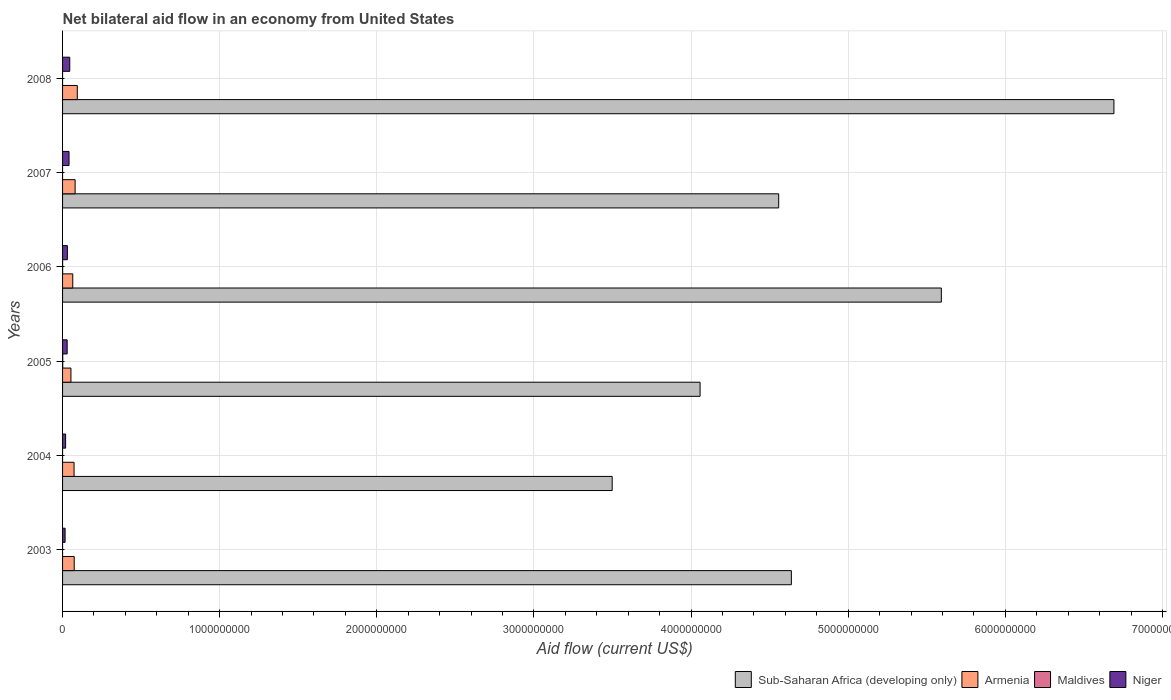In how many cases, is the number of bars for a given year not equal to the number of legend labels?
Make the answer very short. 4. What is the net bilateral aid flow in Niger in 2003?
Keep it short and to the point. 1.61e+07. Across all years, what is the maximum net bilateral aid flow in Sub-Saharan Africa (developing only)?
Ensure brevity in your answer.  6.69e+09. Across all years, what is the minimum net bilateral aid flow in Sub-Saharan Africa (developing only)?
Your answer should be compact. 3.50e+09. What is the total net bilateral aid flow in Niger in the graph?
Provide a succinct answer. 1.82e+08. What is the difference between the net bilateral aid flow in Armenia in 2003 and that in 2006?
Offer a very short reply. 9.31e+06. What is the difference between the net bilateral aid flow in Niger in 2006 and the net bilateral aid flow in Armenia in 2008?
Keep it short and to the point. -6.32e+07. What is the average net bilateral aid flow in Armenia per year?
Your answer should be very brief. 7.32e+07. In the year 2003, what is the difference between the net bilateral aid flow in Niger and net bilateral aid flow in Sub-Saharan Africa (developing only)?
Provide a succinct answer. -4.62e+09. In how many years, is the net bilateral aid flow in Sub-Saharan Africa (developing only) greater than 5200000000 US$?
Your answer should be very brief. 2. What is the ratio of the net bilateral aid flow in Armenia in 2005 to that in 2006?
Your answer should be very brief. 0.82. Is the net bilateral aid flow in Armenia in 2004 less than that in 2008?
Provide a succinct answer. Yes. Is the difference between the net bilateral aid flow in Niger in 2004 and 2005 greater than the difference between the net bilateral aid flow in Sub-Saharan Africa (developing only) in 2004 and 2005?
Offer a very short reply. Yes. What is the difference between the highest and the second highest net bilateral aid flow in Armenia?
Provide a succinct answer. 1.39e+07. What is the difference between the highest and the lowest net bilateral aid flow in Sub-Saharan Africa (developing only)?
Make the answer very short. 3.19e+09. In how many years, is the net bilateral aid flow in Armenia greater than the average net bilateral aid flow in Armenia taken over all years?
Keep it short and to the point. 3. Is the sum of the net bilateral aid flow in Niger in 2005 and 2007 greater than the maximum net bilateral aid flow in Maldives across all years?
Provide a succinct answer. Yes. Is it the case that in every year, the sum of the net bilateral aid flow in Armenia and net bilateral aid flow in Maldives is greater than the net bilateral aid flow in Sub-Saharan Africa (developing only)?
Keep it short and to the point. No. How many years are there in the graph?
Offer a very short reply. 6. Are the values on the major ticks of X-axis written in scientific E-notation?
Ensure brevity in your answer.  No. Does the graph contain any zero values?
Offer a terse response. Yes. Does the graph contain grids?
Offer a very short reply. Yes. Where does the legend appear in the graph?
Offer a terse response. Bottom right. How many legend labels are there?
Your response must be concise. 4. How are the legend labels stacked?
Make the answer very short. Horizontal. What is the title of the graph?
Give a very brief answer. Net bilateral aid flow in an economy from United States. What is the Aid flow (current US$) in Sub-Saharan Africa (developing only) in 2003?
Your response must be concise. 4.64e+09. What is the Aid flow (current US$) in Armenia in 2003?
Offer a terse response. 7.42e+07. What is the Aid flow (current US$) in Maldives in 2003?
Ensure brevity in your answer.  0. What is the Aid flow (current US$) in Niger in 2003?
Provide a short and direct response. 1.61e+07. What is the Aid flow (current US$) of Sub-Saharan Africa (developing only) in 2004?
Ensure brevity in your answer.  3.50e+09. What is the Aid flow (current US$) in Armenia in 2004?
Your answer should be very brief. 7.31e+07. What is the Aid flow (current US$) in Maldives in 2004?
Your answer should be very brief. 0. What is the Aid flow (current US$) in Niger in 2004?
Your answer should be compact. 1.93e+07. What is the Aid flow (current US$) of Sub-Saharan Africa (developing only) in 2005?
Your answer should be very brief. 4.06e+09. What is the Aid flow (current US$) of Armenia in 2005?
Offer a very short reply. 5.33e+07. What is the Aid flow (current US$) of Maldives in 2005?
Your answer should be compact. 1.09e+06. What is the Aid flow (current US$) of Niger in 2005?
Provide a short and direct response. 2.92e+07. What is the Aid flow (current US$) of Sub-Saharan Africa (developing only) in 2006?
Keep it short and to the point. 5.59e+09. What is the Aid flow (current US$) of Armenia in 2006?
Offer a very short reply. 6.49e+07. What is the Aid flow (current US$) of Niger in 2006?
Offer a terse response. 3.06e+07. What is the Aid flow (current US$) of Sub-Saharan Africa (developing only) in 2007?
Your answer should be very brief. 4.56e+09. What is the Aid flow (current US$) of Armenia in 2007?
Provide a succinct answer. 7.99e+07. What is the Aid flow (current US$) of Niger in 2007?
Provide a short and direct response. 4.13e+07. What is the Aid flow (current US$) in Sub-Saharan Africa (developing only) in 2008?
Ensure brevity in your answer.  6.69e+09. What is the Aid flow (current US$) in Armenia in 2008?
Ensure brevity in your answer.  9.38e+07. What is the Aid flow (current US$) of Maldives in 2008?
Offer a terse response. 0. What is the Aid flow (current US$) of Niger in 2008?
Your answer should be compact. 4.59e+07. Across all years, what is the maximum Aid flow (current US$) of Sub-Saharan Africa (developing only)?
Provide a short and direct response. 6.69e+09. Across all years, what is the maximum Aid flow (current US$) of Armenia?
Give a very brief answer. 9.38e+07. Across all years, what is the maximum Aid flow (current US$) of Maldives?
Your answer should be very brief. 1.09e+06. Across all years, what is the maximum Aid flow (current US$) in Niger?
Your answer should be compact. 4.59e+07. Across all years, what is the minimum Aid flow (current US$) in Sub-Saharan Africa (developing only)?
Offer a terse response. 3.50e+09. Across all years, what is the minimum Aid flow (current US$) of Armenia?
Ensure brevity in your answer.  5.33e+07. Across all years, what is the minimum Aid flow (current US$) of Maldives?
Offer a terse response. 0. Across all years, what is the minimum Aid flow (current US$) in Niger?
Provide a succinct answer. 1.61e+07. What is the total Aid flow (current US$) of Sub-Saharan Africa (developing only) in the graph?
Your answer should be compact. 2.90e+1. What is the total Aid flow (current US$) in Armenia in the graph?
Make the answer very short. 4.39e+08. What is the total Aid flow (current US$) of Maldives in the graph?
Offer a very short reply. 1.46e+06. What is the total Aid flow (current US$) of Niger in the graph?
Your answer should be compact. 1.82e+08. What is the difference between the Aid flow (current US$) of Sub-Saharan Africa (developing only) in 2003 and that in 2004?
Provide a short and direct response. 1.14e+09. What is the difference between the Aid flow (current US$) in Armenia in 2003 and that in 2004?
Make the answer very short. 1.05e+06. What is the difference between the Aid flow (current US$) of Niger in 2003 and that in 2004?
Your response must be concise. -3.19e+06. What is the difference between the Aid flow (current US$) in Sub-Saharan Africa (developing only) in 2003 and that in 2005?
Give a very brief answer. 5.81e+08. What is the difference between the Aid flow (current US$) of Armenia in 2003 and that in 2005?
Provide a succinct answer. 2.09e+07. What is the difference between the Aid flow (current US$) in Niger in 2003 and that in 2005?
Offer a terse response. -1.31e+07. What is the difference between the Aid flow (current US$) in Sub-Saharan Africa (developing only) in 2003 and that in 2006?
Your answer should be very brief. -9.54e+08. What is the difference between the Aid flow (current US$) of Armenia in 2003 and that in 2006?
Provide a short and direct response. 9.31e+06. What is the difference between the Aid flow (current US$) in Niger in 2003 and that in 2006?
Your response must be concise. -1.44e+07. What is the difference between the Aid flow (current US$) of Sub-Saharan Africa (developing only) in 2003 and that in 2007?
Your answer should be very brief. 8.07e+07. What is the difference between the Aid flow (current US$) in Armenia in 2003 and that in 2007?
Provide a succinct answer. -5.73e+06. What is the difference between the Aid flow (current US$) of Niger in 2003 and that in 2007?
Keep it short and to the point. -2.52e+07. What is the difference between the Aid flow (current US$) of Sub-Saharan Africa (developing only) in 2003 and that in 2008?
Ensure brevity in your answer.  -2.05e+09. What is the difference between the Aid flow (current US$) in Armenia in 2003 and that in 2008?
Your response must be concise. -1.96e+07. What is the difference between the Aid flow (current US$) of Niger in 2003 and that in 2008?
Give a very brief answer. -2.97e+07. What is the difference between the Aid flow (current US$) in Sub-Saharan Africa (developing only) in 2004 and that in 2005?
Ensure brevity in your answer.  -5.59e+08. What is the difference between the Aid flow (current US$) of Armenia in 2004 and that in 2005?
Provide a short and direct response. 1.99e+07. What is the difference between the Aid flow (current US$) of Niger in 2004 and that in 2005?
Your answer should be very brief. -9.88e+06. What is the difference between the Aid flow (current US$) of Sub-Saharan Africa (developing only) in 2004 and that in 2006?
Provide a short and direct response. -2.09e+09. What is the difference between the Aid flow (current US$) of Armenia in 2004 and that in 2006?
Your answer should be very brief. 8.26e+06. What is the difference between the Aid flow (current US$) in Niger in 2004 and that in 2006?
Keep it short and to the point. -1.12e+07. What is the difference between the Aid flow (current US$) of Sub-Saharan Africa (developing only) in 2004 and that in 2007?
Your answer should be compact. -1.06e+09. What is the difference between the Aid flow (current US$) in Armenia in 2004 and that in 2007?
Provide a succinct answer. -6.78e+06. What is the difference between the Aid flow (current US$) of Niger in 2004 and that in 2007?
Offer a terse response. -2.20e+07. What is the difference between the Aid flow (current US$) in Sub-Saharan Africa (developing only) in 2004 and that in 2008?
Give a very brief answer. -3.19e+09. What is the difference between the Aid flow (current US$) of Armenia in 2004 and that in 2008?
Your response must be concise. -2.06e+07. What is the difference between the Aid flow (current US$) of Niger in 2004 and that in 2008?
Ensure brevity in your answer.  -2.65e+07. What is the difference between the Aid flow (current US$) in Sub-Saharan Africa (developing only) in 2005 and that in 2006?
Your response must be concise. -1.54e+09. What is the difference between the Aid flow (current US$) in Armenia in 2005 and that in 2006?
Your answer should be very brief. -1.16e+07. What is the difference between the Aid flow (current US$) of Maldives in 2005 and that in 2006?
Offer a terse response. 7.20e+05. What is the difference between the Aid flow (current US$) of Niger in 2005 and that in 2006?
Your answer should be very brief. -1.36e+06. What is the difference between the Aid flow (current US$) of Sub-Saharan Africa (developing only) in 2005 and that in 2007?
Ensure brevity in your answer.  -5.00e+08. What is the difference between the Aid flow (current US$) of Armenia in 2005 and that in 2007?
Give a very brief answer. -2.67e+07. What is the difference between the Aid flow (current US$) in Niger in 2005 and that in 2007?
Keep it short and to the point. -1.21e+07. What is the difference between the Aid flow (current US$) of Sub-Saharan Africa (developing only) in 2005 and that in 2008?
Offer a terse response. -2.63e+09. What is the difference between the Aid flow (current US$) of Armenia in 2005 and that in 2008?
Provide a short and direct response. -4.05e+07. What is the difference between the Aid flow (current US$) of Niger in 2005 and that in 2008?
Offer a terse response. -1.67e+07. What is the difference between the Aid flow (current US$) of Sub-Saharan Africa (developing only) in 2006 and that in 2007?
Provide a short and direct response. 1.04e+09. What is the difference between the Aid flow (current US$) in Armenia in 2006 and that in 2007?
Your answer should be compact. -1.50e+07. What is the difference between the Aid flow (current US$) in Niger in 2006 and that in 2007?
Give a very brief answer. -1.07e+07. What is the difference between the Aid flow (current US$) of Sub-Saharan Africa (developing only) in 2006 and that in 2008?
Your answer should be compact. -1.10e+09. What is the difference between the Aid flow (current US$) in Armenia in 2006 and that in 2008?
Give a very brief answer. -2.89e+07. What is the difference between the Aid flow (current US$) in Niger in 2006 and that in 2008?
Provide a short and direct response. -1.53e+07. What is the difference between the Aid flow (current US$) in Sub-Saharan Africa (developing only) in 2007 and that in 2008?
Your response must be concise. -2.13e+09. What is the difference between the Aid flow (current US$) of Armenia in 2007 and that in 2008?
Ensure brevity in your answer.  -1.39e+07. What is the difference between the Aid flow (current US$) of Niger in 2007 and that in 2008?
Your answer should be compact. -4.58e+06. What is the difference between the Aid flow (current US$) in Sub-Saharan Africa (developing only) in 2003 and the Aid flow (current US$) in Armenia in 2004?
Offer a very short reply. 4.57e+09. What is the difference between the Aid flow (current US$) of Sub-Saharan Africa (developing only) in 2003 and the Aid flow (current US$) of Niger in 2004?
Your response must be concise. 4.62e+09. What is the difference between the Aid flow (current US$) of Armenia in 2003 and the Aid flow (current US$) of Niger in 2004?
Your answer should be very brief. 5.49e+07. What is the difference between the Aid flow (current US$) of Sub-Saharan Africa (developing only) in 2003 and the Aid flow (current US$) of Armenia in 2005?
Make the answer very short. 4.58e+09. What is the difference between the Aid flow (current US$) of Sub-Saharan Africa (developing only) in 2003 and the Aid flow (current US$) of Maldives in 2005?
Provide a succinct answer. 4.64e+09. What is the difference between the Aid flow (current US$) in Sub-Saharan Africa (developing only) in 2003 and the Aid flow (current US$) in Niger in 2005?
Make the answer very short. 4.61e+09. What is the difference between the Aid flow (current US$) in Armenia in 2003 and the Aid flow (current US$) in Maldives in 2005?
Give a very brief answer. 7.31e+07. What is the difference between the Aid flow (current US$) of Armenia in 2003 and the Aid flow (current US$) of Niger in 2005?
Your response must be concise. 4.50e+07. What is the difference between the Aid flow (current US$) in Sub-Saharan Africa (developing only) in 2003 and the Aid flow (current US$) in Armenia in 2006?
Offer a terse response. 4.57e+09. What is the difference between the Aid flow (current US$) in Sub-Saharan Africa (developing only) in 2003 and the Aid flow (current US$) in Maldives in 2006?
Keep it short and to the point. 4.64e+09. What is the difference between the Aid flow (current US$) in Sub-Saharan Africa (developing only) in 2003 and the Aid flow (current US$) in Niger in 2006?
Offer a very short reply. 4.61e+09. What is the difference between the Aid flow (current US$) in Armenia in 2003 and the Aid flow (current US$) in Maldives in 2006?
Offer a very short reply. 7.38e+07. What is the difference between the Aid flow (current US$) in Armenia in 2003 and the Aid flow (current US$) in Niger in 2006?
Keep it short and to the point. 4.36e+07. What is the difference between the Aid flow (current US$) in Sub-Saharan Africa (developing only) in 2003 and the Aid flow (current US$) in Armenia in 2007?
Your response must be concise. 4.56e+09. What is the difference between the Aid flow (current US$) of Sub-Saharan Africa (developing only) in 2003 and the Aid flow (current US$) of Niger in 2007?
Ensure brevity in your answer.  4.60e+09. What is the difference between the Aid flow (current US$) in Armenia in 2003 and the Aid flow (current US$) in Niger in 2007?
Your answer should be very brief. 3.29e+07. What is the difference between the Aid flow (current US$) of Sub-Saharan Africa (developing only) in 2003 and the Aid flow (current US$) of Armenia in 2008?
Offer a very short reply. 4.54e+09. What is the difference between the Aid flow (current US$) in Sub-Saharan Africa (developing only) in 2003 and the Aid flow (current US$) in Niger in 2008?
Give a very brief answer. 4.59e+09. What is the difference between the Aid flow (current US$) in Armenia in 2003 and the Aid flow (current US$) in Niger in 2008?
Offer a terse response. 2.83e+07. What is the difference between the Aid flow (current US$) in Sub-Saharan Africa (developing only) in 2004 and the Aid flow (current US$) in Armenia in 2005?
Your answer should be compact. 3.44e+09. What is the difference between the Aid flow (current US$) of Sub-Saharan Africa (developing only) in 2004 and the Aid flow (current US$) of Maldives in 2005?
Give a very brief answer. 3.50e+09. What is the difference between the Aid flow (current US$) of Sub-Saharan Africa (developing only) in 2004 and the Aid flow (current US$) of Niger in 2005?
Keep it short and to the point. 3.47e+09. What is the difference between the Aid flow (current US$) of Armenia in 2004 and the Aid flow (current US$) of Maldives in 2005?
Offer a very short reply. 7.20e+07. What is the difference between the Aid flow (current US$) in Armenia in 2004 and the Aid flow (current US$) in Niger in 2005?
Your answer should be compact. 4.39e+07. What is the difference between the Aid flow (current US$) in Sub-Saharan Africa (developing only) in 2004 and the Aid flow (current US$) in Armenia in 2006?
Keep it short and to the point. 3.43e+09. What is the difference between the Aid flow (current US$) in Sub-Saharan Africa (developing only) in 2004 and the Aid flow (current US$) in Maldives in 2006?
Offer a very short reply. 3.50e+09. What is the difference between the Aid flow (current US$) of Sub-Saharan Africa (developing only) in 2004 and the Aid flow (current US$) of Niger in 2006?
Provide a succinct answer. 3.47e+09. What is the difference between the Aid flow (current US$) of Armenia in 2004 and the Aid flow (current US$) of Maldives in 2006?
Provide a succinct answer. 7.28e+07. What is the difference between the Aid flow (current US$) in Armenia in 2004 and the Aid flow (current US$) in Niger in 2006?
Give a very brief answer. 4.26e+07. What is the difference between the Aid flow (current US$) in Sub-Saharan Africa (developing only) in 2004 and the Aid flow (current US$) in Armenia in 2007?
Keep it short and to the point. 3.42e+09. What is the difference between the Aid flow (current US$) in Sub-Saharan Africa (developing only) in 2004 and the Aid flow (current US$) in Niger in 2007?
Make the answer very short. 3.46e+09. What is the difference between the Aid flow (current US$) of Armenia in 2004 and the Aid flow (current US$) of Niger in 2007?
Give a very brief answer. 3.19e+07. What is the difference between the Aid flow (current US$) in Sub-Saharan Africa (developing only) in 2004 and the Aid flow (current US$) in Armenia in 2008?
Offer a terse response. 3.40e+09. What is the difference between the Aid flow (current US$) of Sub-Saharan Africa (developing only) in 2004 and the Aid flow (current US$) of Niger in 2008?
Give a very brief answer. 3.45e+09. What is the difference between the Aid flow (current US$) of Armenia in 2004 and the Aid flow (current US$) of Niger in 2008?
Keep it short and to the point. 2.73e+07. What is the difference between the Aid flow (current US$) of Sub-Saharan Africa (developing only) in 2005 and the Aid flow (current US$) of Armenia in 2006?
Offer a terse response. 3.99e+09. What is the difference between the Aid flow (current US$) in Sub-Saharan Africa (developing only) in 2005 and the Aid flow (current US$) in Maldives in 2006?
Make the answer very short. 4.06e+09. What is the difference between the Aid flow (current US$) of Sub-Saharan Africa (developing only) in 2005 and the Aid flow (current US$) of Niger in 2006?
Keep it short and to the point. 4.03e+09. What is the difference between the Aid flow (current US$) in Armenia in 2005 and the Aid flow (current US$) in Maldives in 2006?
Your answer should be very brief. 5.29e+07. What is the difference between the Aid flow (current US$) of Armenia in 2005 and the Aid flow (current US$) of Niger in 2006?
Offer a very short reply. 2.27e+07. What is the difference between the Aid flow (current US$) of Maldives in 2005 and the Aid flow (current US$) of Niger in 2006?
Your answer should be compact. -2.95e+07. What is the difference between the Aid flow (current US$) in Sub-Saharan Africa (developing only) in 2005 and the Aid flow (current US$) in Armenia in 2007?
Your answer should be very brief. 3.98e+09. What is the difference between the Aid flow (current US$) of Sub-Saharan Africa (developing only) in 2005 and the Aid flow (current US$) of Niger in 2007?
Make the answer very short. 4.02e+09. What is the difference between the Aid flow (current US$) of Armenia in 2005 and the Aid flow (current US$) of Niger in 2007?
Keep it short and to the point. 1.20e+07. What is the difference between the Aid flow (current US$) in Maldives in 2005 and the Aid flow (current US$) in Niger in 2007?
Give a very brief answer. -4.02e+07. What is the difference between the Aid flow (current US$) in Sub-Saharan Africa (developing only) in 2005 and the Aid flow (current US$) in Armenia in 2008?
Provide a succinct answer. 3.96e+09. What is the difference between the Aid flow (current US$) of Sub-Saharan Africa (developing only) in 2005 and the Aid flow (current US$) of Niger in 2008?
Offer a terse response. 4.01e+09. What is the difference between the Aid flow (current US$) in Armenia in 2005 and the Aid flow (current US$) in Niger in 2008?
Offer a very short reply. 7.40e+06. What is the difference between the Aid flow (current US$) of Maldives in 2005 and the Aid flow (current US$) of Niger in 2008?
Make the answer very short. -4.48e+07. What is the difference between the Aid flow (current US$) of Sub-Saharan Africa (developing only) in 2006 and the Aid flow (current US$) of Armenia in 2007?
Keep it short and to the point. 5.51e+09. What is the difference between the Aid flow (current US$) of Sub-Saharan Africa (developing only) in 2006 and the Aid flow (current US$) of Niger in 2007?
Make the answer very short. 5.55e+09. What is the difference between the Aid flow (current US$) of Armenia in 2006 and the Aid flow (current US$) of Niger in 2007?
Offer a very short reply. 2.36e+07. What is the difference between the Aid flow (current US$) of Maldives in 2006 and the Aid flow (current US$) of Niger in 2007?
Offer a terse response. -4.09e+07. What is the difference between the Aid flow (current US$) in Sub-Saharan Africa (developing only) in 2006 and the Aid flow (current US$) in Armenia in 2008?
Ensure brevity in your answer.  5.50e+09. What is the difference between the Aid flow (current US$) in Sub-Saharan Africa (developing only) in 2006 and the Aid flow (current US$) in Niger in 2008?
Keep it short and to the point. 5.55e+09. What is the difference between the Aid flow (current US$) in Armenia in 2006 and the Aid flow (current US$) in Niger in 2008?
Provide a short and direct response. 1.90e+07. What is the difference between the Aid flow (current US$) in Maldives in 2006 and the Aid flow (current US$) in Niger in 2008?
Offer a very short reply. -4.55e+07. What is the difference between the Aid flow (current US$) of Sub-Saharan Africa (developing only) in 2007 and the Aid flow (current US$) of Armenia in 2008?
Offer a terse response. 4.46e+09. What is the difference between the Aid flow (current US$) of Sub-Saharan Africa (developing only) in 2007 and the Aid flow (current US$) of Niger in 2008?
Offer a terse response. 4.51e+09. What is the difference between the Aid flow (current US$) in Armenia in 2007 and the Aid flow (current US$) in Niger in 2008?
Keep it short and to the point. 3.41e+07. What is the average Aid flow (current US$) in Sub-Saharan Africa (developing only) per year?
Provide a succinct answer. 4.84e+09. What is the average Aid flow (current US$) of Armenia per year?
Provide a short and direct response. 7.32e+07. What is the average Aid flow (current US$) in Maldives per year?
Your answer should be very brief. 2.43e+05. What is the average Aid flow (current US$) in Niger per year?
Keep it short and to the point. 3.04e+07. In the year 2003, what is the difference between the Aid flow (current US$) of Sub-Saharan Africa (developing only) and Aid flow (current US$) of Armenia?
Offer a terse response. 4.56e+09. In the year 2003, what is the difference between the Aid flow (current US$) in Sub-Saharan Africa (developing only) and Aid flow (current US$) in Niger?
Provide a succinct answer. 4.62e+09. In the year 2003, what is the difference between the Aid flow (current US$) of Armenia and Aid flow (current US$) of Niger?
Your response must be concise. 5.81e+07. In the year 2004, what is the difference between the Aid flow (current US$) of Sub-Saharan Africa (developing only) and Aid flow (current US$) of Armenia?
Provide a succinct answer. 3.42e+09. In the year 2004, what is the difference between the Aid flow (current US$) of Sub-Saharan Africa (developing only) and Aid flow (current US$) of Niger?
Give a very brief answer. 3.48e+09. In the year 2004, what is the difference between the Aid flow (current US$) in Armenia and Aid flow (current US$) in Niger?
Keep it short and to the point. 5.38e+07. In the year 2005, what is the difference between the Aid flow (current US$) of Sub-Saharan Africa (developing only) and Aid flow (current US$) of Armenia?
Provide a succinct answer. 4.00e+09. In the year 2005, what is the difference between the Aid flow (current US$) in Sub-Saharan Africa (developing only) and Aid flow (current US$) in Maldives?
Ensure brevity in your answer.  4.06e+09. In the year 2005, what is the difference between the Aid flow (current US$) of Sub-Saharan Africa (developing only) and Aid flow (current US$) of Niger?
Provide a succinct answer. 4.03e+09. In the year 2005, what is the difference between the Aid flow (current US$) in Armenia and Aid flow (current US$) in Maldives?
Ensure brevity in your answer.  5.22e+07. In the year 2005, what is the difference between the Aid flow (current US$) in Armenia and Aid flow (current US$) in Niger?
Your response must be concise. 2.41e+07. In the year 2005, what is the difference between the Aid flow (current US$) in Maldives and Aid flow (current US$) in Niger?
Provide a short and direct response. -2.81e+07. In the year 2006, what is the difference between the Aid flow (current US$) in Sub-Saharan Africa (developing only) and Aid flow (current US$) in Armenia?
Your answer should be compact. 5.53e+09. In the year 2006, what is the difference between the Aid flow (current US$) in Sub-Saharan Africa (developing only) and Aid flow (current US$) in Maldives?
Offer a terse response. 5.59e+09. In the year 2006, what is the difference between the Aid flow (current US$) in Sub-Saharan Africa (developing only) and Aid flow (current US$) in Niger?
Your answer should be compact. 5.56e+09. In the year 2006, what is the difference between the Aid flow (current US$) of Armenia and Aid flow (current US$) of Maldives?
Provide a succinct answer. 6.45e+07. In the year 2006, what is the difference between the Aid flow (current US$) of Armenia and Aid flow (current US$) of Niger?
Provide a short and direct response. 3.43e+07. In the year 2006, what is the difference between the Aid flow (current US$) of Maldives and Aid flow (current US$) of Niger?
Provide a short and direct response. -3.02e+07. In the year 2007, what is the difference between the Aid flow (current US$) of Sub-Saharan Africa (developing only) and Aid flow (current US$) of Armenia?
Give a very brief answer. 4.48e+09. In the year 2007, what is the difference between the Aid flow (current US$) in Sub-Saharan Africa (developing only) and Aid flow (current US$) in Niger?
Make the answer very short. 4.52e+09. In the year 2007, what is the difference between the Aid flow (current US$) in Armenia and Aid flow (current US$) in Niger?
Your answer should be very brief. 3.86e+07. In the year 2008, what is the difference between the Aid flow (current US$) in Sub-Saharan Africa (developing only) and Aid flow (current US$) in Armenia?
Give a very brief answer. 6.60e+09. In the year 2008, what is the difference between the Aid flow (current US$) in Sub-Saharan Africa (developing only) and Aid flow (current US$) in Niger?
Provide a succinct answer. 6.65e+09. In the year 2008, what is the difference between the Aid flow (current US$) in Armenia and Aid flow (current US$) in Niger?
Your response must be concise. 4.79e+07. What is the ratio of the Aid flow (current US$) in Sub-Saharan Africa (developing only) in 2003 to that in 2004?
Keep it short and to the point. 1.33. What is the ratio of the Aid flow (current US$) of Armenia in 2003 to that in 2004?
Provide a succinct answer. 1.01. What is the ratio of the Aid flow (current US$) of Niger in 2003 to that in 2004?
Offer a very short reply. 0.83. What is the ratio of the Aid flow (current US$) of Sub-Saharan Africa (developing only) in 2003 to that in 2005?
Your answer should be compact. 1.14. What is the ratio of the Aid flow (current US$) in Armenia in 2003 to that in 2005?
Give a very brief answer. 1.39. What is the ratio of the Aid flow (current US$) of Niger in 2003 to that in 2005?
Offer a very short reply. 0.55. What is the ratio of the Aid flow (current US$) in Sub-Saharan Africa (developing only) in 2003 to that in 2006?
Ensure brevity in your answer.  0.83. What is the ratio of the Aid flow (current US$) of Armenia in 2003 to that in 2006?
Offer a very short reply. 1.14. What is the ratio of the Aid flow (current US$) in Niger in 2003 to that in 2006?
Offer a terse response. 0.53. What is the ratio of the Aid flow (current US$) of Sub-Saharan Africa (developing only) in 2003 to that in 2007?
Give a very brief answer. 1.02. What is the ratio of the Aid flow (current US$) of Armenia in 2003 to that in 2007?
Your answer should be compact. 0.93. What is the ratio of the Aid flow (current US$) in Niger in 2003 to that in 2007?
Make the answer very short. 0.39. What is the ratio of the Aid flow (current US$) in Sub-Saharan Africa (developing only) in 2003 to that in 2008?
Offer a very short reply. 0.69. What is the ratio of the Aid flow (current US$) of Armenia in 2003 to that in 2008?
Your response must be concise. 0.79. What is the ratio of the Aid flow (current US$) in Niger in 2003 to that in 2008?
Make the answer very short. 0.35. What is the ratio of the Aid flow (current US$) of Sub-Saharan Africa (developing only) in 2004 to that in 2005?
Your answer should be compact. 0.86. What is the ratio of the Aid flow (current US$) in Armenia in 2004 to that in 2005?
Provide a succinct answer. 1.37. What is the ratio of the Aid flow (current US$) of Niger in 2004 to that in 2005?
Provide a succinct answer. 0.66. What is the ratio of the Aid flow (current US$) in Sub-Saharan Africa (developing only) in 2004 to that in 2006?
Offer a very short reply. 0.63. What is the ratio of the Aid flow (current US$) of Armenia in 2004 to that in 2006?
Provide a short and direct response. 1.13. What is the ratio of the Aid flow (current US$) in Niger in 2004 to that in 2006?
Your answer should be very brief. 0.63. What is the ratio of the Aid flow (current US$) of Sub-Saharan Africa (developing only) in 2004 to that in 2007?
Provide a short and direct response. 0.77. What is the ratio of the Aid flow (current US$) in Armenia in 2004 to that in 2007?
Your response must be concise. 0.92. What is the ratio of the Aid flow (current US$) of Niger in 2004 to that in 2007?
Give a very brief answer. 0.47. What is the ratio of the Aid flow (current US$) of Sub-Saharan Africa (developing only) in 2004 to that in 2008?
Provide a short and direct response. 0.52. What is the ratio of the Aid flow (current US$) of Armenia in 2004 to that in 2008?
Make the answer very short. 0.78. What is the ratio of the Aid flow (current US$) in Niger in 2004 to that in 2008?
Offer a very short reply. 0.42. What is the ratio of the Aid flow (current US$) of Sub-Saharan Africa (developing only) in 2005 to that in 2006?
Provide a short and direct response. 0.73. What is the ratio of the Aid flow (current US$) in Armenia in 2005 to that in 2006?
Your answer should be very brief. 0.82. What is the ratio of the Aid flow (current US$) of Maldives in 2005 to that in 2006?
Make the answer very short. 2.95. What is the ratio of the Aid flow (current US$) of Niger in 2005 to that in 2006?
Offer a terse response. 0.96. What is the ratio of the Aid flow (current US$) of Sub-Saharan Africa (developing only) in 2005 to that in 2007?
Keep it short and to the point. 0.89. What is the ratio of the Aid flow (current US$) in Armenia in 2005 to that in 2007?
Give a very brief answer. 0.67. What is the ratio of the Aid flow (current US$) in Niger in 2005 to that in 2007?
Offer a very short reply. 0.71. What is the ratio of the Aid flow (current US$) in Sub-Saharan Africa (developing only) in 2005 to that in 2008?
Your response must be concise. 0.61. What is the ratio of the Aid flow (current US$) of Armenia in 2005 to that in 2008?
Provide a succinct answer. 0.57. What is the ratio of the Aid flow (current US$) in Niger in 2005 to that in 2008?
Keep it short and to the point. 0.64. What is the ratio of the Aid flow (current US$) in Sub-Saharan Africa (developing only) in 2006 to that in 2007?
Your answer should be compact. 1.23. What is the ratio of the Aid flow (current US$) in Armenia in 2006 to that in 2007?
Provide a succinct answer. 0.81. What is the ratio of the Aid flow (current US$) of Niger in 2006 to that in 2007?
Give a very brief answer. 0.74. What is the ratio of the Aid flow (current US$) in Sub-Saharan Africa (developing only) in 2006 to that in 2008?
Your response must be concise. 0.84. What is the ratio of the Aid flow (current US$) of Armenia in 2006 to that in 2008?
Keep it short and to the point. 0.69. What is the ratio of the Aid flow (current US$) in Niger in 2006 to that in 2008?
Ensure brevity in your answer.  0.67. What is the ratio of the Aid flow (current US$) of Sub-Saharan Africa (developing only) in 2007 to that in 2008?
Your answer should be compact. 0.68. What is the ratio of the Aid flow (current US$) of Armenia in 2007 to that in 2008?
Keep it short and to the point. 0.85. What is the ratio of the Aid flow (current US$) in Niger in 2007 to that in 2008?
Offer a very short reply. 0.9. What is the difference between the highest and the second highest Aid flow (current US$) in Sub-Saharan Africa (developing only)?
Give a very brief answer. 1.10e+09. What is the difference between the highest and the second highest Aid flow (current US$) of Armenia?
Your answer should be very brief. 1.39e+07. What is the difference between the highest and the second highest Aid flow (current US$) in Niger?
Your response must be concise. 4.58e+06. What is the difference between the highest and the lowest Aid flow (current US$) of Sub-Saharan Africa (developing only)?
Your answer should be very brief. 3.19e+09. What is the difference between the highest and the lowest Aid flow (current US$) of Armenia?
Your answer should be compact. 4.05e+07. What is the difference between the highest and the lowest Aid flow (current US$) of Maldives?
Provide a succinct answer. 1.09e+06. What is the difference between the highest and the lowest Aid flow (current US$) of Niger?
Offer a very short reply. 2.97e+07. 